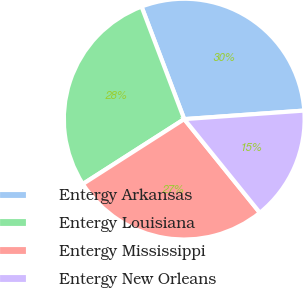<chart> <loc_0><loc_0><loc_500><loc_500><pie_chart><fcel>Entergy Arkansas<fcel>Entergy Louisiana<fcel>Entergy Mississippi<fcel>Entergy New Orleans<nl><fcel>29.64%<fcel>28.29%<fcel>26.76%<fcel>15.32%<nl></chart> 